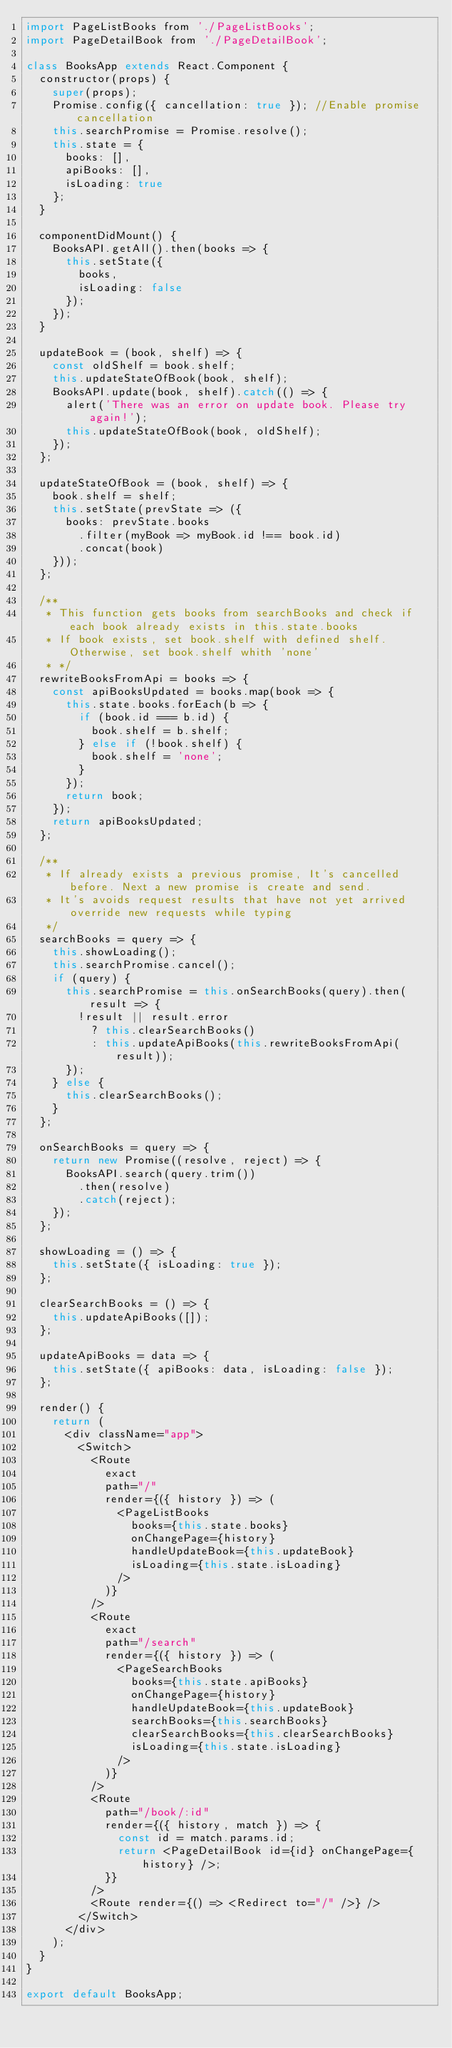<code> <loc_0><loc_0><loc_500><loc_500><_JavaScript_>import PageListBooks from './PageListBooks';
import PageDetailBook from './PageDetailBook';

class BooksApp extends React.Component {
  constructor(props) {
    super(props);
    Promise.config({ cancellation: true }); //Enable promise cancellation
    this.searchPromise = Promise.resolve();
    this.state = {
      books: [],
      apiBooks: [],
      isLoading: true
    };
  }

  componentDidMount() {
    BooksAPI.getAll().then(books => {
      this.setState({
        books,
        isLoading: false
      });
    });
  }

  updateBook = (book, shelf) => {
    const oldShelf = book.shelf;
    this.updateStateOfBook(book, shelf);
    BooksAPI.update(book, shelf).catch(() => {
      alert('There was an error on update book. Please try again!');
      this.updateStateOfBook(book, oldShelf);
    });
  };

  updateStateOfBook = (book, shelf) => {
    book.shelf = shelf;
    this.setState(prevState => ({
      books: prevState.books
        .filter(myBook => myBook.id !== book.id)
        .concat(book)
    }));
  };

  /**
   * This function gets books from searchBooks and check if each book already exists in this.state.books
   * If book exists, set book.shelf with defined shelf. Otherwise, set book.shelf whith 'none'
   * */
  rewriteBooksFromApi = books => {
    const apiBooksUpdated = books.map(book => {
      this.state.books.forEach(b => {
        if (book.id === b.id) {
          book.shelf = b.shelf;
        } else if (!book.shelf) {
          book.shelf = 'none';
        }
      });
      return book;
    });
    return apiBooksUpdated;
  };

  /**
   * If already exists a previous promise, It's cancelled before. Next a new promise is create and send.
   * It's avoids request results that have not yet arrived override new requests while typing
   */
  searchBooks = query => {
    this.showLoading();
    this.searchPromise.cancel();
    if (query) {
      this.searchPromise = this.onSearchBooks(query).then(result => {
        !result || result.error
          ? this.clearSearchBooks()
          : this.updateApiBooks(this.rewriteBooksFromApi(result));
      });
    } else {
      this.clearSearchBooks();
    }
  };

  onSearchBooks = query => {
    return new Promise((resolve, reject) => {
      BooksAPI.search(query.trim())
        .then(resolve)
        .catch(reject);
    });
  };

  showLoading = () => {
    this.setState({ isLoading: true });
  };

  clearSearchBooks = () => {
    this.updateApiBooks([]);
  };

  updateApiBooks = data => {
    this.setState({ apiBooks: data, isLoading: false });
  };

  render() {
    return (
      <div className="app">
        <Switch>
          <Route
            exact
            path="/"
            render={({ history }) => (
              <PageListBooks
                books={this.state.books}
                onChangePage={history}
                handleUpdateBook={this.updateBook}
                isLoading={this.state.isLoading}
              />
            )}
          />
          <Route
            exact
            path="/search"
            render={({ history }) => (
              <PageSearchBooks
                books={this.state.apiBooks}
                onChangePage={history}
                handleUpdateBook={this.updateBook}
                searchBooks={this.searchBooks}
                clearSearchBooks={this.clearSearchBooks}
                isLoading={this.state.isLoading}
              />
            )}
          />
          <Route
            path="/book/:id"
            render={({ history, match }) => {
              const id = match.params.id;
              return <PageDetailBook id={id} onChangePage={history} />;
            }}
          />
          <Route render={() => <Redirect to="/" />} />
        </Switch>
      </div>
    );
  }
}

export default BooksApp;
</code> 